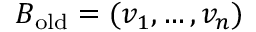Convert formula to latex. <formula><loc_0><loc_0><loc_500><loc_500>B _ { o l d } = ( v _ { 1 } , \dots , v _ { n } )</formula> 